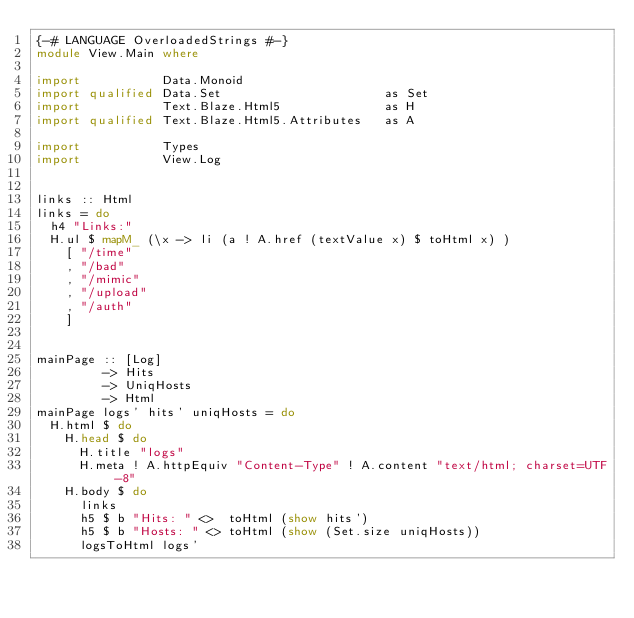Convert code to text. <code><loc_0><loc_0><loc_500><loc_500><_Haskell_>{-# LANGUAGE OverloadedStrings #-}
module View.Main where

import           Data.Monoid
import qualified Data.Set                      as Set
import           Text.Blaze.Html5              as H
import qualified Text.Blaze.Html5.Attributes   as A

import           Types
import           View.Log


links :: Html
links = do
  h4 "Links:"
  H.ul $ mapM_ (\x -> li (a ! A.href (textValue x) $ toHtml x) )
    [ "/time"
    , "/bad"
    , "/mimic"
    , "/upload"
    , "/auth"
    ]


mainPage :: [Log]
         -> Hits
         -> UniqHosts
         -> Html
mainPage logs' hits' uniqHosts = do
  H.html $ do
    H.head $ do
      H.title "logs"
      H.meta ! A.httpEquiv "Content-Type" ! A.content "text/html; charset=UTF-8"
    H.body $ do
      links
      h5 $ b "Hits: " <>  toHtml (show hits')
      h5 $ b "Hosts: " <> toHtml (show (Set.size uniqHosts))
      logsToHtml logs'
</code> 